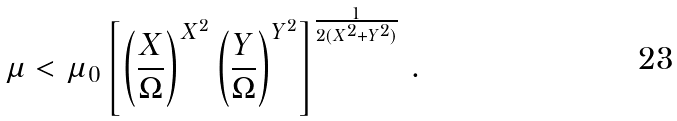<formula> <loc_0><loc_0><loc_500><loc_500>\mu < \mu _ { 0 } \left [ \left ( \frac { X } { \Omega } \right ) ^ { X ^ { 2 } } \left ( \frac { Y } { \Omega } \right ) ^ { Y ^ { 2 } } \right ] ^ { \frac { 1 } { 2 ( X ^ { 2 } + Y ^ { 2 } ) } } \, .</formula> 